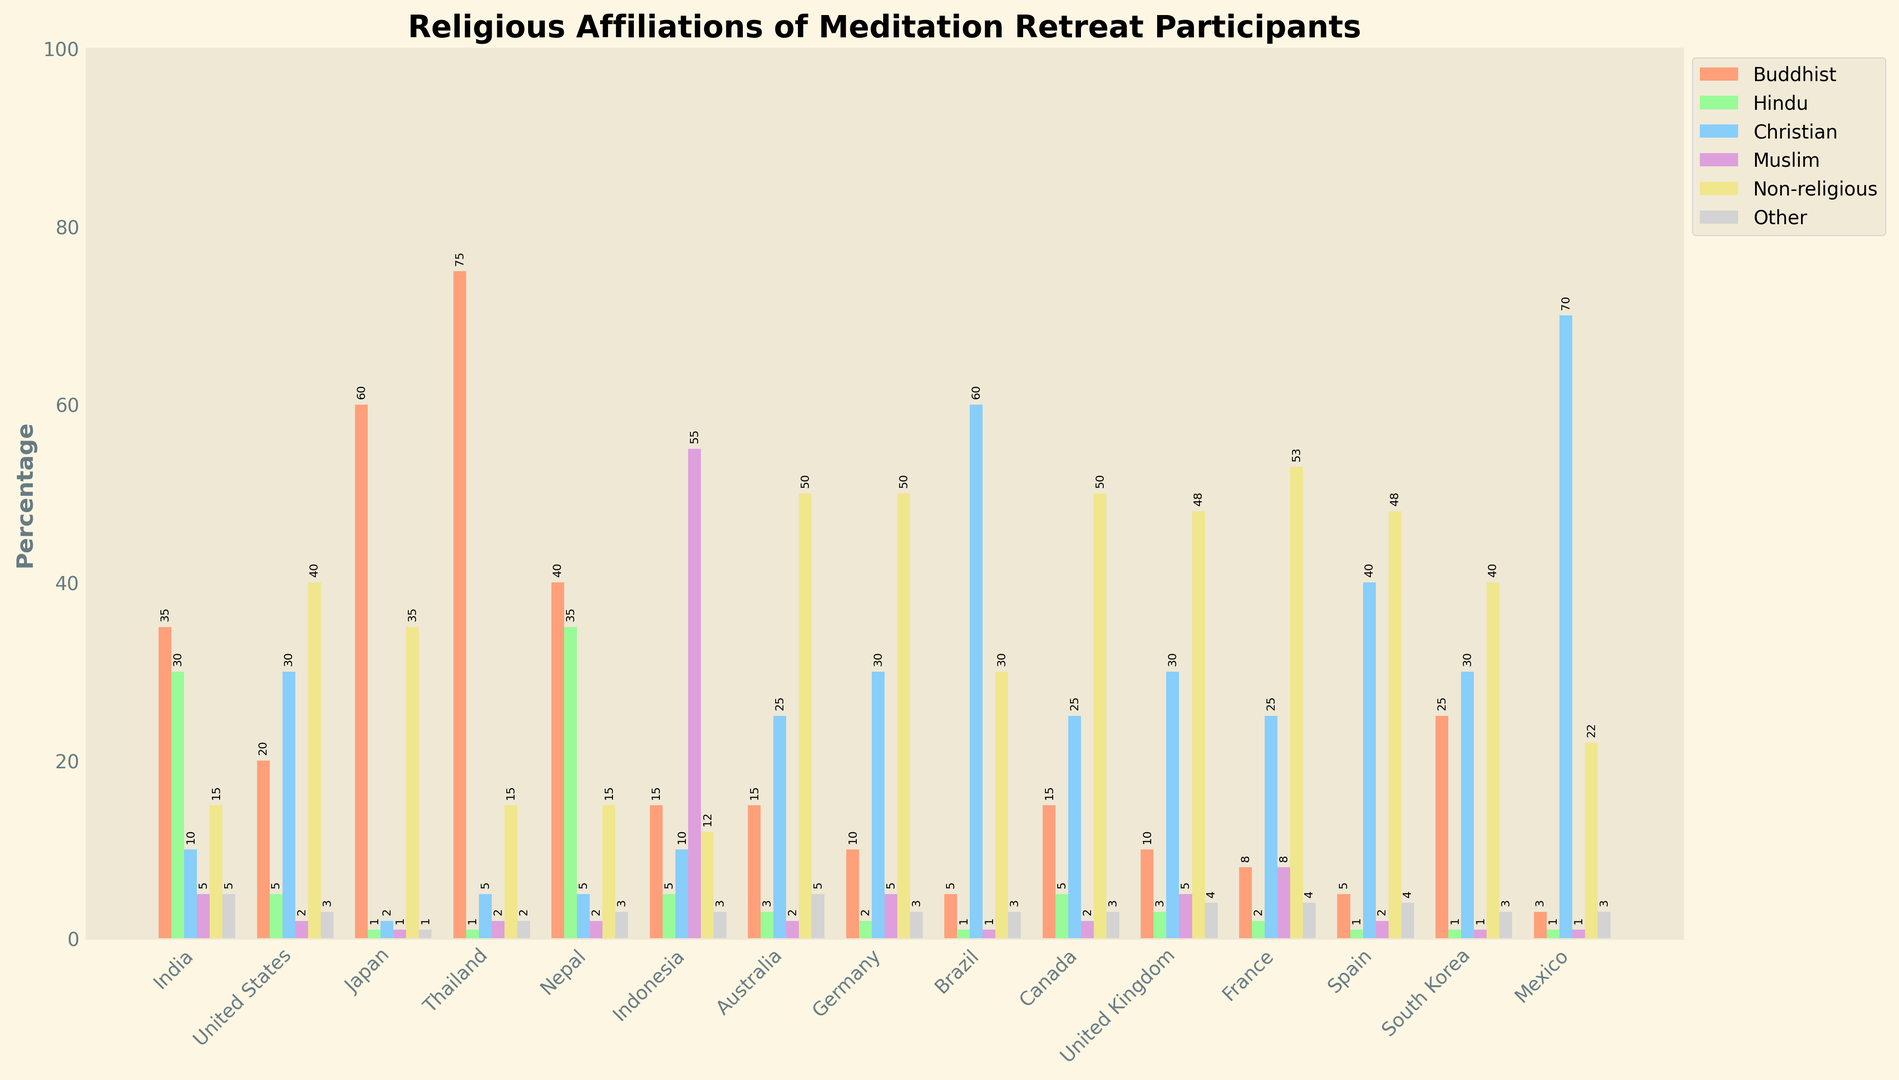How many countries have a higher percentage of Non-religious participants than Christian participants? First, identify the countries where the Non-religious percentage is higher than the Christian percentage. Compare the bar heights for 'Non-religious' and 'Christian’ for each country. The countries meeting this criterion are the United States, Australia, Germany, France, and Spain, making a total of 5 countries.
Answer: 5 In which country is the percentage of Muslim participants significantly higher than in other countries? Compare the heights of the 'Muslim' bars for all countries. Indonesia has the highest Muslim participation at 55%, significantly higher than the other countries.
Answer: Indonesia What’s the total percentage of Buddhist participants across all countries? Sum the percentages for 'Buddhist' participants from each country. The total is 35 (India) + 20 (United States) + 60 (Japan) + 75 (Thailand) + 40 (Nepal) + 15 (Indonesia) + 15 (Australia) + 10 (Germany) + 5 (Brazil) + 15 (Canada) + 10 (United Kingdom) + 8 (France) + 5 (Spain) + 25 (South Korea) + 3 (Mexico) = 341%.
Answer: 341% Which country has an equal percentage of 'Buddhist' and 'Other' participants? Identify the countries where the heights of the 'Buddhist' and 'Other' bars are the same. India has 35% for both 'Buddhist' and 'Other' participants.
Answer: India Among the countries listed, which one has the highest percentage of Christian participants? Look for the country with the tallest bar for 'Christian'. Mexico has the highest percentage at 70%.
Answer: Mexico How many countries have a ‘Non-religious’ participation rate of 50%? Count the countries where the 'Non-religious' bar reaches exactly 50%. The countries are Australia, Germany, and Canada.
Answer: 3 Which two countries have the closest percentages of Hindu participants? Compare the heights of the 'Hindu' bars to find the closest values. India and Nepal have very close percentages, with 30% and 35% respectively.
Answer: India and Nepal In which country do 'Buddhist' participants constitute the largest percentage of all participant groups? Check for the largest 'Buddhist' bar compared to the others. Thailand has the largest 'Buddhist' group at 75%.
Answer: Thailand What is the average percentage of ‘Other’ participants across all countries? Sum the percentages for 'Other' participants from each country and divide by the number of countries (15). The total is 5 (India) + 3 (United States) + 1 (Japan) + 2 (Thailand) + 3 (Nepal) + 3 (Indonesia) + 5 (Australia) + 3 (Germany) + 3 (Brazil) + 3 (Canada) + 4 (United Kingdom) + 4 (France) + 4 (Spain) + 3 (South Korea) + 3 (Mexico) = 48. Hence, the average is 48 / 15 ≈ 3.2%.
Answer: 3.2% Which country shows an equal percentage of Buddhist and Hindu participants, and what is that percentage? Identify the country where the 'Buddhist' and 'Hindu' bars are of equal height and note the percentage. Nepal has 35% for both 'Buddhist' and 'Hindu'.
Answer: Nepal, 35% 